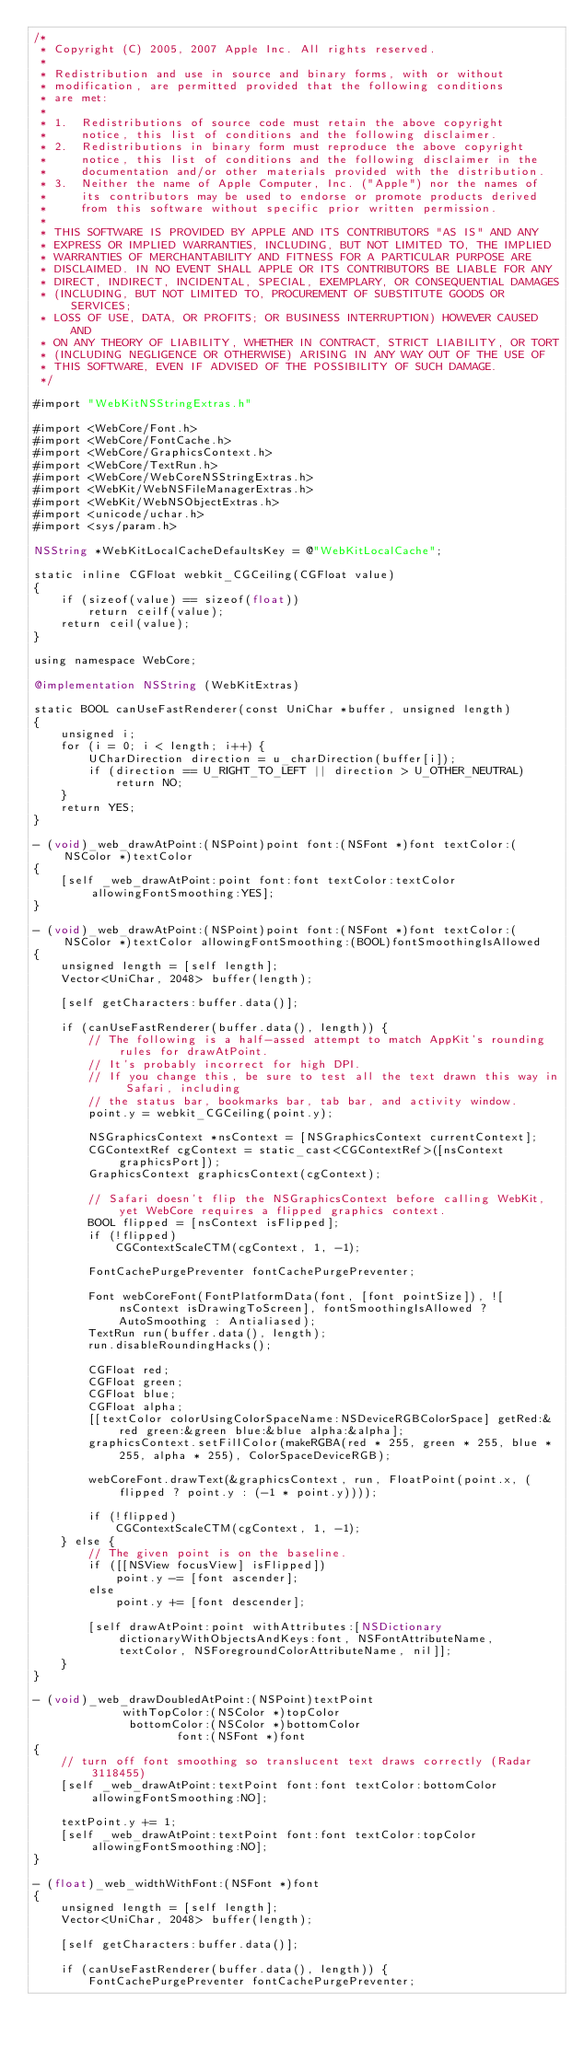<code> <loc_0><loc_0><loc_500><loc_500><_ObjectiveC_>/*
 * Copyright (C) 2005, 2007 Apple Inc. All rights reserved.
 *
 * Redistribution and use in source and binary forms, with or without
 * modification, are permitted provided that the following conditions
 * are met:
 *
 * 1.  Redistributions of source code must retain the above copyright
 *     notice, this list of conditions and the following disclaimer. 
 * 2.  Redistributions in binary form must reproduce the above copyright
 *     notice, this list of conditions and the following disclaimer in the
 *     documentation and/or other materials provided with the distribution. 
 * 3.  Neither the name of Apple Computer, Inc. ("Apple") nor the names of
 *     its contributors may be used to endorse or promote products derived
 *     from this software without specific prior written permission. 
 *
 * THIS SOFTWARE IS PROVIDED BY APPLE AND ITS CONTRIBUTORS "AS IS" AND ANY
 * EXPRESS OR IMPLIED WARRANTIES, INCLUDING, BUT NOT LIMITED TO, THE IMPLIED
 * WARRANTIES OF MERCHANTABILITY AND FITNESS FOR A PARTICULAR PURPOSE ARE
 * DISCLAIMED. IN NO EVENT SHALL APPLE OR ITS CONTRIBUTORS BE LIABLE FOR ANY
 * DIRECT, INDIRECT, INCIDENTAL, SPECIAL, EXEMPLARY, OR CONSEQUENTIAL DAMAGES
 * (INCLUDING, BUT NOT LIMITED TO, PROCUREMENT OF SUBSTITUTE GOODS OR SERVICES;
 * LOSS OF USE, DATA, OR PROFITS; OR BUSINESS INTERRUPTION) HOWEVER CAUSED AND
 * ON ANY THEORY OF LIABILITY, WHETHER IN CONTRACT, STRICT LIABILITY, OR TORT
 * (INCLUDING NEGLIGENCE OR OTHERWISE) ARISING IN ANY WAY OUT OF THE USE OF
 * THIS SOFTWARE, EVEN IF ADVISED OF THE POSSIBILITY OF SUCH DAMAGE.
 */

#import "WebKitNSStringExtras.h"

#import <WebCore/Font.h>
#import <WebCore/FontCache.h>
#import <WebCore/GraphicsContext.h>
#import <WebCore/TextRun.h>
#import <WebCore/WebCoreNSStringExtras.h>
#import <WebKit/WebNSFileManagerExtras.h>
#import <WebKit/WebNSObjectExtras.h>
#import <unicode/uchar.h>
#import <sys/param.h>

NSString *WebKitLocalCacheDefaultsKey = @"WebKitLocalCache";

static inline CGFloat webkit_CGCeiling(CGFloat value)
{
    if (sizeof(value) == sizeof(float))
        return ceilf(value);
    return ceil(value);
}

using namespace WebCore;

@implementation NSString (WebKitExtras)

static BOOL canUseFastRenderer(const UniChar *buffer, unsigned length)
{
    unsigned i;
    for (i = 0; i < length; i++) {
        UCharDirection direction = u_charDirection(buffer[i]);
        if (direction == U_RIGHT_TO_LEFT || direction > U_OTHER_NEUTRAL)
            return NO;
    }
    return YES;
}

- (void)_web_drawAtPoint:(NSPoint)point font:(NSFont *)font textColor:(NSColor *)textColor
{
    [self _web_drawAtPoint:point font:font textColor:textColor allowingFontSmoothing:YES];
}

- (void)_web_drawAtPoint:(NSPoint)point font:(NSFont *)font textColor:(NSColor *)textColor allowingFontSmoothing:(BOOL)fontSmoothingIsAllowed
{
    unsigned length = [self length];
    Vector<UniChar, 2048> buffer(length);

    [self getCharacters:buffer.data()];

    if (canUseFastRenderer(buffer.data(), length)) {
        // The following is a half-assed attempt to match AppKit's rounding rules for drawAtPoint.
        // It's probably incorrect for high DPI.
        // If you change this, be sure to test all the text drawn this way in Safari, including
        // the status bar, bookmarks bar, tab bar, and activity window.
        point.y = webkit_CGCeiling(point.y);

        NSGraphicsContext *nsContext = [NSGraphicsContext currentContext];
        CGContextRef cgContext = static_cast<CGContextRef>([nsContext graphicsPort]);
        GraphicsContext graphicsContext(cgContext);    

        // Safari doesn't flip the NSGraphicsContext before calling WebKit, yet WebCore requires a flipped graphics context.
        BOOL flipped = [nsContext isFlipped];
        if (!flipped)
            CGContextScaleCTM(cgContext, 1, -1);

        FontCachePurgePreventer fontCachePurgePreventer;

        Font webCoreFont(FontPlatformData(font, [font pointSize]), ![nsContext isDrawingToScreen], fontSmoothingIsAllowed ? AutoSmoothing : Antialiased);
        TextRun run(buffer.data(), length);
        run.disableRoundingHacks();

        CGFloat red;
        CGFloat green;
        CGFloat blue;
        CGFloat alpha;
        [[textColor colorUsingColorSpaceName:NSDeviceRGBColorSpace] getRed:&red green:&green blue:&blue alpha:&alpha];
        graphicsContext.setFillColor(makeRGBA(red * 255, green * 255, blue * 255, alpha * 255), ColorSpaceDeviceRGB);

        webCoreFont.drawText(&graphicsContext, run, FloatPoint(point.x, (flipped ? point.y : (-1 * point.y))));

        if (!flipped)
            CGContextScaleCTM(cgContext, 1, -1);
    } else {
        // The given point is on the baseline.
        if ([[NSView focusView] isFlipped])
            point.y -= [font ascender];
        else
            point.y += [font descender];

        [self drawAtPoint:point withAttributes:[NSDictionary dictionaryWithObjectsAndKeys:font, NSFontAttributeName, textColor, NSForegroundColorAttributeName, nil]];
    }
}

- (void)_web_drawDoubledAtPoint:(NSPoint)textPoint
             withTopColor:(NSColor *)topColor
              bottomColor:(NSColor *)bottomColor
                     font:(NSFont *)font
{
    // turn off font smoothing so translucent text draws correctly (Radar 3118455)
    [self _web_drawAtPoint:textPoint font:font textColor:bottomColor allowingFontSmoothing:NO];

    textPoint.y += 1;
    [self _web_drawAtPoint:textPoint font:font textColor:topColor allowingFontSmoothing:NO];
}

- (float)_web_widthWithFont:(NSFont *)font
{
    unsigned length = [self length];
    Vector<UniChar, 2048> buffer(length);

    [self getCharacters:buffer.data()];

    if (canUseFastRenderer(buffer.data(), length)) {
        FontCachePurgePreventer fontCachePurgePreventer;
</code> 